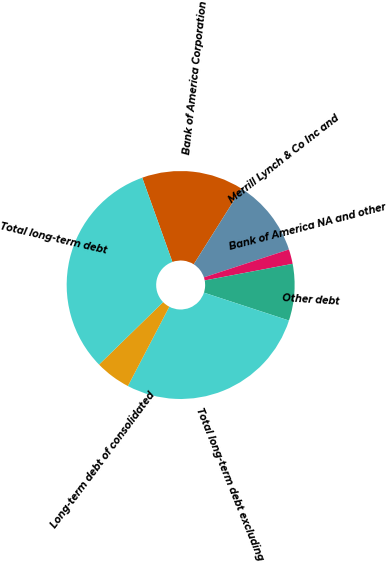<chart> <loc_0><loc_0><loc_500><loc_500><pie_chart><fcel>Bank of America Corporation<fcel>Merrill Lynch & Co Inc and<fcel>Bank of America NA and other<fcel>Other debt<fcel>Total long-term debt excluding<fcel>Long-term debt of consolidated<fcel>Total long-term debt<nl><fcel>14.43%<fcel>11.0%<fcel>2.07%<fcel>8.02%<fcel>27.62%<fcel>5.04%<fcel>31.83%<nl></chart> 